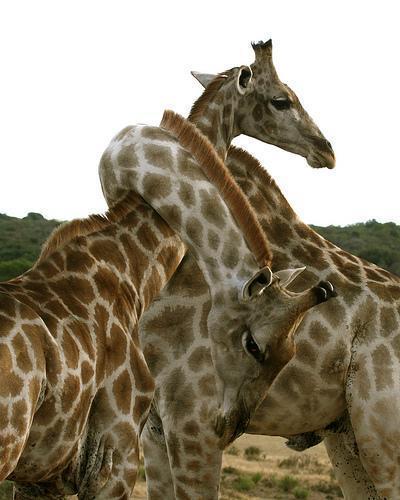How many giraffe's are there?
Give a very brief answer. 2. 